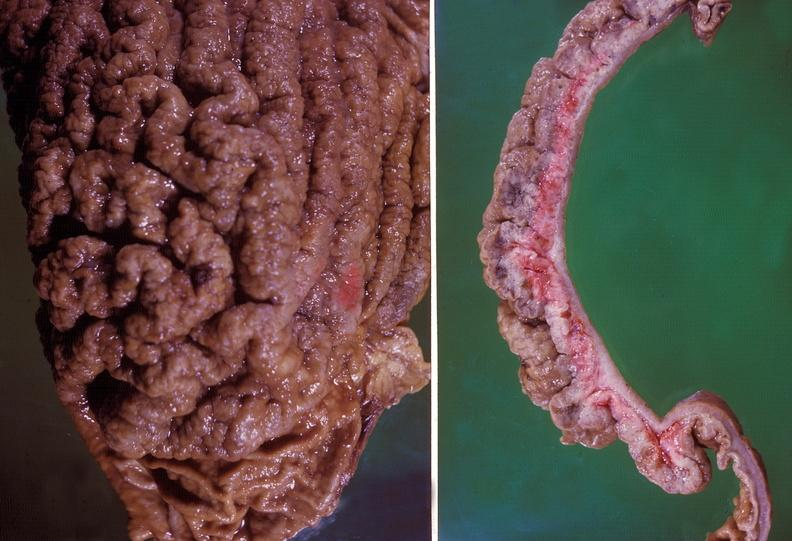does this image show stomach, giant rugose hypertrophy?
Answer the question using a single word or phrase. Yes 